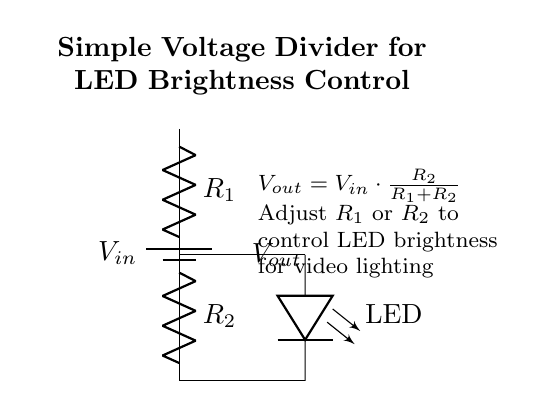What is the purpose of this circuit? The purpose of this circuit is to control the brightness of an LED. This is achieved by using a voltage divider to adjust the voltage output to the LED.
Answer: control LED brightness What components are used in this circuit? The main components in the circuit are a battery, two resistors labeled R1 and R2, and an LED. These components work together to create the voltage divider.
Answer: battery, resistors, LED What does Vout represent in this circuit? Vout represents the output voltage across R2, which is applied to the LED. It is critical for determining how bright the LED will glow based on the resistor values.
Answer: output voltage across R2 How is Vout calculated? Vout is calculated using the formula Vout equals Vin multiplied by the ratio of R2 over the sum of R1 and R2. This relationship shows how the resistors influence the output voltage.
Answer: Vout = Vin * (R2 / (R1 + R2)) What happens if R1 is increased? If R1 is increased, the output voltage Vout decreases, resulting in a dimmer LED. This occurs because a larger R1 reduces the voltage drop across R2, lowering the voltage to the LED.
Answer: LED brightness decreases What would happen if R2 is decreased? If R2 is decreased, the output voltage Vout increases, causing the LED to glow brighter. A smaller R2 means a smaller voltage drop across R2 compared to R1, resulting in higher Vout.
Answer: LED brightness increases What is the relationship between R1 and R2 for maximum LED brightness? For maximum LED brightness, R2 should be minimized relative to R1, which allows for a larger voltage drop across the LED. Hence, to achieve maximum brightness, R1 must be much larger than R2.
Answer: R1 much larger than R2 